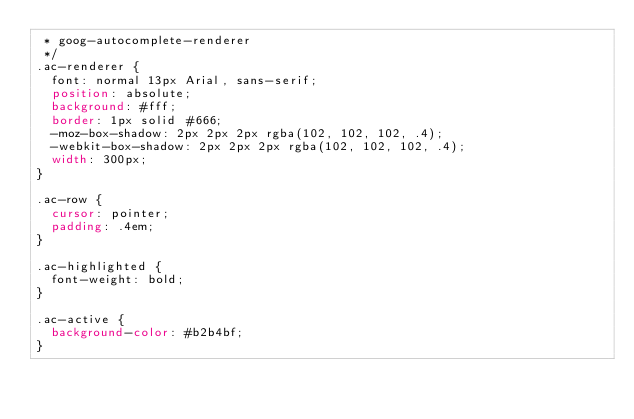<code> <loc_0><loc_0><loc_500><loc_500><_CSS_> * goog-autocomplete-renderer
 */
.ac-renderer {
  font: normal 13px Arial, sans-serif;
  position: absolute;
  background: #fff;
  border: 1px solid #666;
  -moz-box-shadow: 2px 2px 2px rgba(102, 102, 102, .4);
  -webkit-box-shadow: 2px 2px 2px rgba(102, 102, 102, .4);
  width: 300px;
}

.ac-row {
  cursor: pointer;
  padding: .4em;
}

.ac-highlighted {
  font-weight: bold;
}

.ac-active {
  background-color: #b2b4bf;
}
</code> 